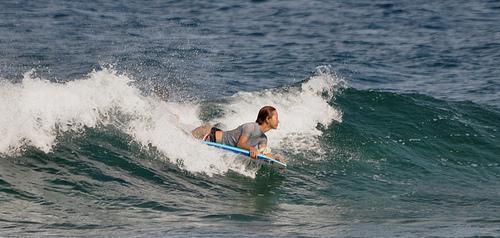How many waves is she riding?
Give a very brief answer. 1. 